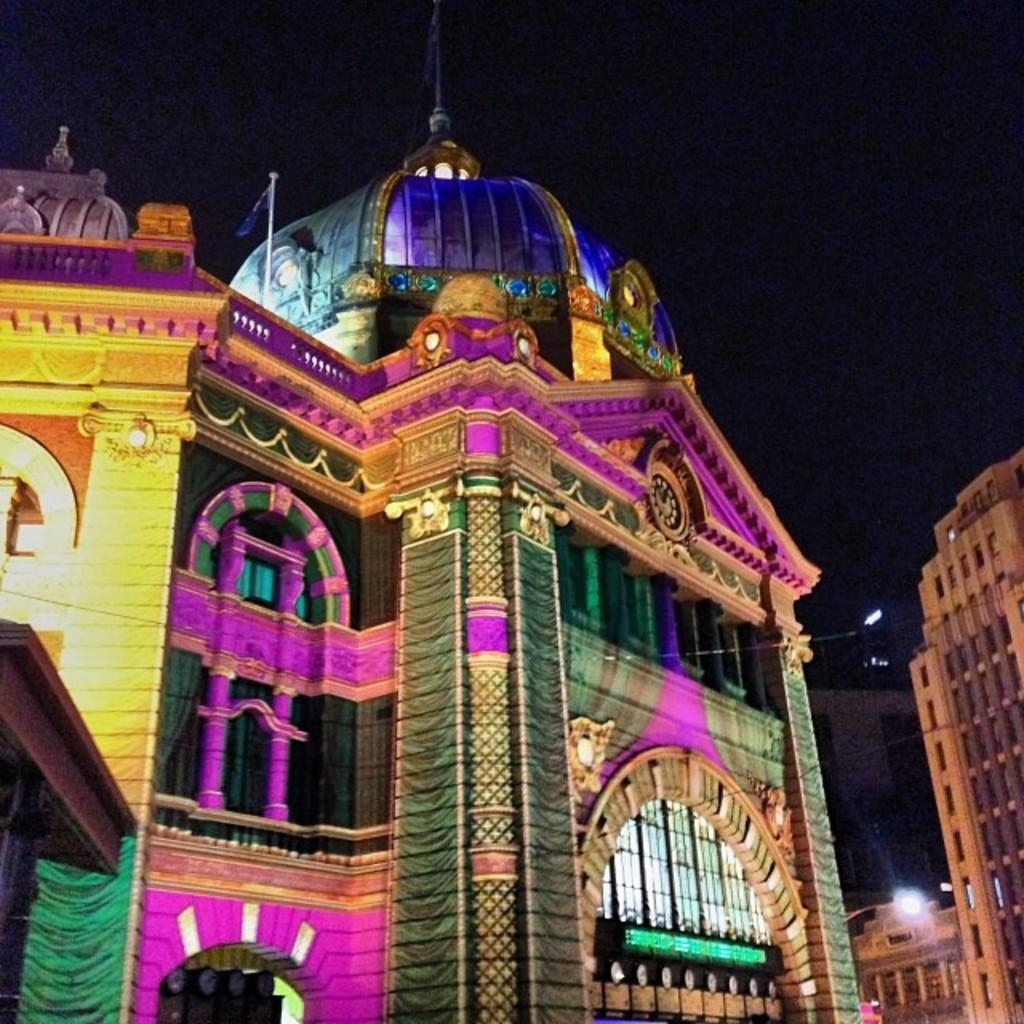What type of structures can be seen in the image? There are buildings in the image. Can you describe any specific characteristics of the buildings? One of the buildings is colorful. How does the island in the image affect the body of the person standing on it? There is no island present in the image; it only features buildings. 